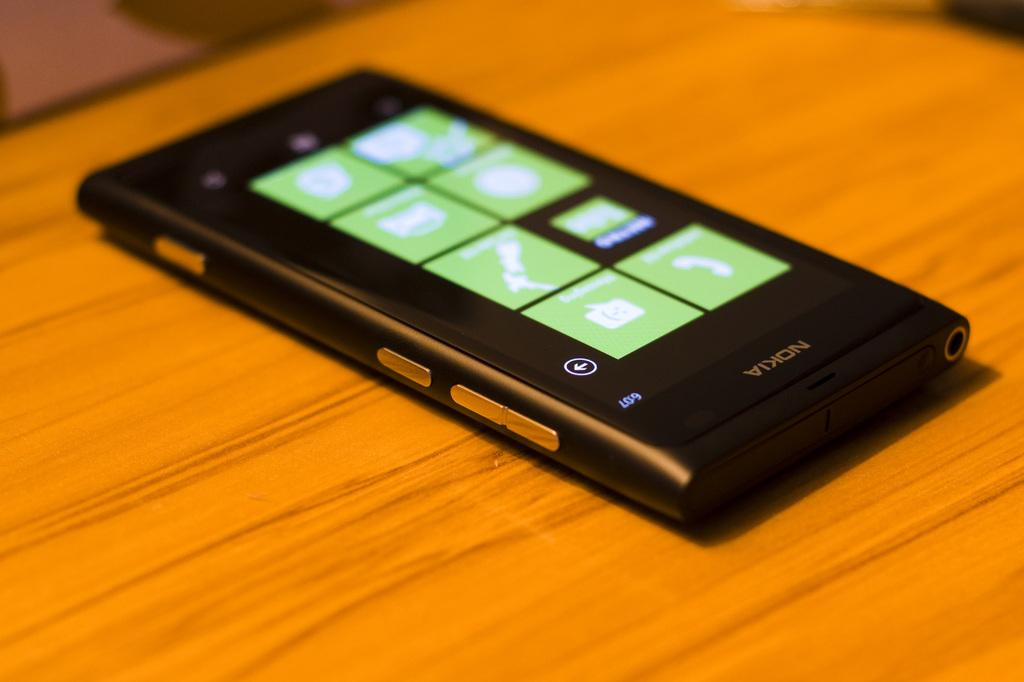<image>
Provide a brief description of the given image. A Nokia phone has multiple green tiles on its display screen. 